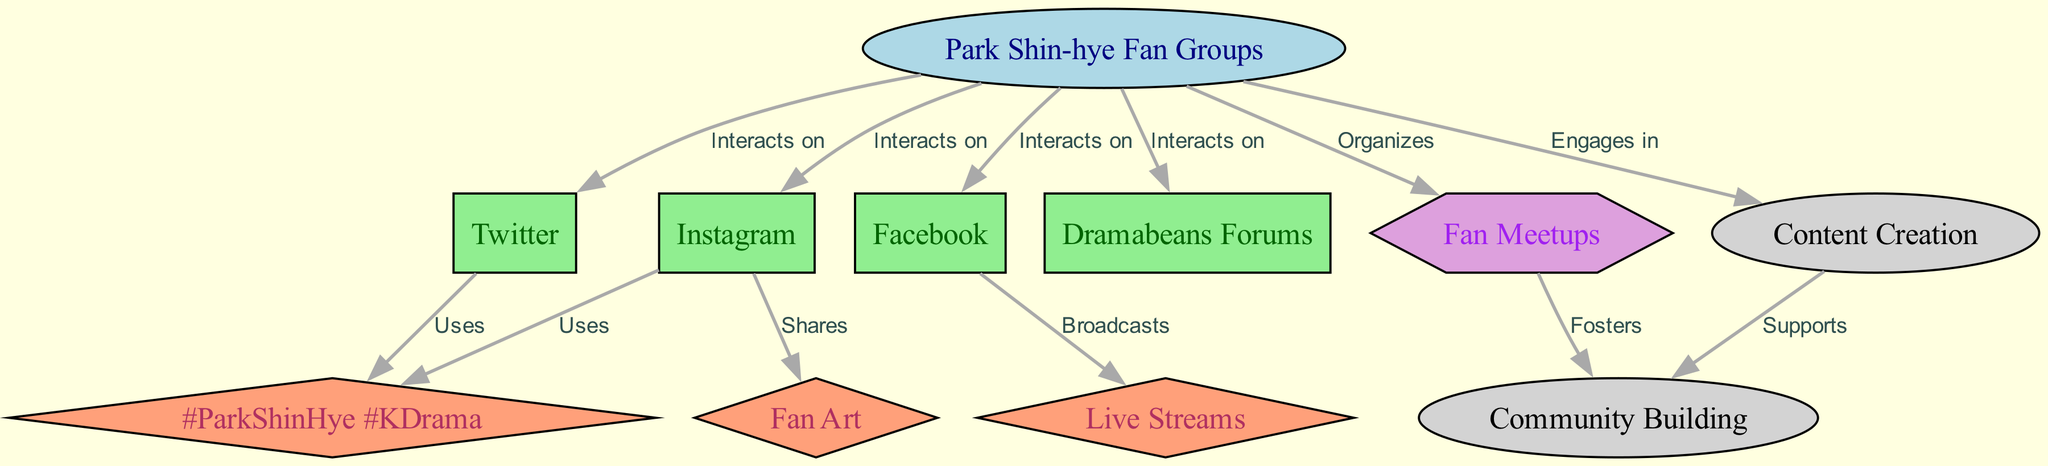What is the total number of nodes in the diagram? There are 11 nodes in the diagram, which can be counted directly from the node list provided.
Answer: 11 Which social media platform interacts with the fan groups? The fan groups interact with four platforms: Twitter, Facebook, Instagram, and Dramabeans Forums.
Answer: Twitter, Facebook, Instagram, Dramabeans Forums What type of content is used on Twitter? The Twitter platform uses hashtags, specifically #ParkShinHye and #KDrama as noted in the connections with the content node labeled "Hashtags."
Answer: Hashtags How many types of activities are indicated in the diagram? The diagram indicates two types of activities: Content Creation and Community Building, which can be observed from the activity nodes present.
Answer: 2 Which platform broadcasts live streams? Facebook is the platform noted for broadcasting live streams, as can be seen in the edge connecting Facebook to the content node "Live Streams."
Answer: Facebook How does fan meetups contribute to community? Fan meetups foster community building, which is highlighted in the edge between the "Fan Meetups" node and the "Community Building" node.
Answer: Fosters Which platforms engage in content creation? The Park Shin-hye fan groups engage in content creation, as directly shown by the edge connecting them to the "Content Creation" activity node.
Answer: Park Shin-hye Fan Groups What color represents the content nodes? The content nodes, which include Hashtags, Live Streams, and Fan Art, are represented in lightsalmon color according to the node styles defined in the diagram.
Answer: Lightsalmon 